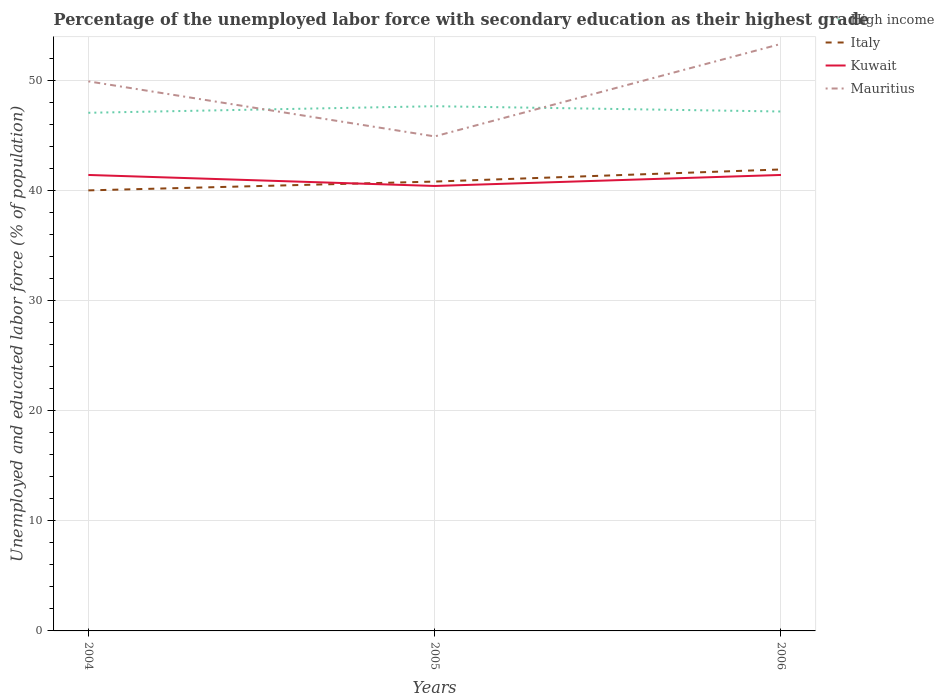How many different coloured lines are there?
Provide a short and direct response. 4. Is the number of lines equal to the number of legend labels?
Your answer should be very brief. Yes. What is the total percentage of the unemployed labor force with secondary education in Mauritius in the graph?
Provide a short and direct response. -3.4. What is the difference between the highest and the second highest percentage of the unemployed labor force with secondary education in Mauritius?
Offer a very short reply. 8.4. What is the difference between the highest and the lowest percentage of the unemployed labor force with secondary education in Italy?
Provide a succinct answer. 1. How many lines are there?
Ensure brevity in your answer.  4. What is the difference between two consecutive major ticks on the Y-axis?
Your answer should be compact. 10. Are the values on the major ticks of Y-axis written in scientific E-notation?
Your response must be concise. No. Does the graph contain any zero values?
Your answer should be very brief. No. How are the legend labels stacked?
Provide a short and direct response. Vertical. What is the title of the graph?
Your response must be concise. Percentage of the unemployed labor force with secondary education as their highest grade. What is the label or title of the X-axis?
Your answer should be compact. Years. What is the label or title of the Y-axis?
Make the answer very short. Unemployed and educated labor force (% of population). What is the Unemployed and educated labor force (% of population) of High income in 2004?
Keep it short and to the point. 47.05. What is the Unemployed and educated labor force (% of population) of Italy in 2004?
Your response must be concise. 40. What is the Unemployed and educated labor force (% of population) in Kuwait in 2004?
Ensure brevity in your answer.  41.4. What is the Unemployed and educated labor force (% of population) of Mauritius in 2004?
Make the answer very short. 49.9. What is the Unemployed and educated labor force (% of population) in High income in 2005?
Your answer should be very brief. 47.64. What is the Unemployed and educated labor force (% of population) in Italy in 2005?
Offer a terse response. 40.8. What is the Unemployed and educated labor force (% of population) of Kuwait in 2005?
Provide a short and direct response. 40.4. What is the Unemployed and educated labor force (% of population) of Mauritius in 2005?
Your response must be concise. 44.9. What is the Unemployed and educated labor force (% of population) of High income in 2006?
Offer a terse response. 47.16. What is the Unemployed and educated labor force (% of population) in Italy in 2006?
Provide a succinct answer. 41.9. What is the Unemployed and educated labor force (% of population) of Kuwait in 2006?
Keep it short and to the point. 41.4. What is the Unemployed and educated labor force (% of population) in Mauritius in 2006?
Provide a short and direct response. 53.3. Across all years, what is the maximum Unemployed and educated labor force (% of population) of High income?
Ensure brevity in your answer.  47.64. Across all years, what is the maximum Unemployed and educated labor force (% of population) in Italy?
Provide a short and direct response. 41.9. Across all years, what is the maximum Unemployed and educated labor force (% of population) of Kuwait?
Ensure brevity in your answer.  41.4. Across all years, what is the maximum Unemployed and educated labor force (% of population) in Mauritius?
Ensure brevity in your answer.  53.3. Across all years, what is the minimum Unemployed and educated labor force (% of population) in High income?
Provide a succinct answer. 47.05. Across all years, what is the minimum Unemployed and educated labor force (% of population) of Italy?
Ensure brevity in your answer.  40. Across all years, what is the minimum Unemployed and educated labor force (% of population) in Kuwait?
Provide a short and direct response. 40.4. Across all years, what is the minimum Unemployed and educated labor force (% of population) of Mauritius?
Your answer should be very brief. 44.9. What is the total Unemployed and educated labor force (% of population) in High income in the graph?
Keep it short and to the point. 141.85. What is the total Unemployed and educated labor force (% of population) in Italy in the graph?
Make the answer very short. 122.7. What is the total Unemployed and educated labor force (% of population) of Kuwait in the graph?
Provide a succinct answer. 123.2. What is the total Unemployed and educated labor force (% of population) in Mauritius in the graph?
Provide a succinct answer. 148.1. What is the difference between the Unemployed and educated labor force (% of population) in High income in 2004 and that in 2005?
Your answer should be compact. -0.6. What is the difference between the Unemployed and educated labor force (% of population) in Kuwait in 2004 and that in 2005?
Give a very brief answer. 1. What is the difference between the Unemployed and educated labor force (% of population) of High income in 2004 and that in 2006?
Your response must be concise. -0.12. What is the difference between the Unemployed and educated labor force (% of population) of Kuwait in 2004 and that in 2006?
Your answer should be very brief. 0. What is the difference between the Unemployed and educated labor force (% of population) in Mauritius in 2004 and that in 2006?
Your response must be concise. -3.4. What is the difference between the Unemployed and educated labor force (% of population) of High income in 2005 and that in 2006?
Offer a very short reply. 0.48. What is the difference between the Unemployed and educated labor force (% of population) of Italy in 2005 and that in 2006?
Provide a short and direct response. -1.1. What is the difference between the Unemployed and educated labor force (% of population) of Kuwait in 2005 and that in 2006?
Offer a very short reply. -1. What is the difference between the Unemployed and educated labor force (% of population) of High income in 2004 and the Unemployed and educated labor force (% of population) of Italy in 2005?
Make the answer very short. 6.25. What is the difference between the Unemployed and educated labor force (% of population) in High income in 2004 and the Unemployed and educated labor force (% of population) in Kuwait in 2005?
Ensure brevity in your answer.  6.65. What is the difference between the Unemployed and educated labor force (% of population) in High income in 2004 and the Unemployed and educated labor force (% of population) in Mauritius in 2005?
Provide a short and direct response. 2.15. What is the difference between the Unemployed and educated labor force (% of population) of Kuwait in 2004 and the Unemployed and educated labor force (% of population) of Mauritius in 2005?
Provide a succinct answer. -3.5. What is the difference between the Unemployed and educated labor force (% of population) in High income in 2004 and the Unemployed and educated labor force (% of population) in Italy in 2006?
Your answer should be very brief. 5.15. What is the difference between the Unemployed and educated labor force (% of population) of High income in 2004 and the Unemployed and educated labor force (% of population) of Kuwait in 2006?
Provide a short and direct response. 5.65. What is the difference between the Unemployed and educated labor force (% of population) of High income in 2004 and the Unemployed and educated labor force (% of population) of Mauritius in 2006?
Your answer should be compact. -6.25. What is the difference between the Unemployed and educated labor force (% of population) in Italy in 2004 and the Unemployed and educated labor force (% of population) in Kuwait in 2006?
Give a very brief answer. -1.4. What is the difference between the Unemployed and educated labor force (% of population) in Italy in 2004 and the Unemployed and educated labor force (% of population) in Mauritius in 2006?
Your answer should be compact. -13.3. What is the difference between the Unemployed and educated labor force (% of population) of High income in 2005 and the Unemployed and educated labor force (% of population) of Italy in 2006?
Offer a very short reply. 5.74. What is the difference between the Unemployed and educated labor force (% of population) in High income in 2005 and the Unemployed and educated labor force (% of population) in Kuwait in 2006?
Keep it short and to the point. 6.24. What is the difference between the Unemployed and educated labor force (% of population) of High income in 2005 and the Unemployed and educated labor force (% of population) of Mauritius in 2006?
Provide a short and direct response. -5.66. What is the difference between the Unemployed and educated labor force (% of population) of Italy in 2005 and the Unemployed and educated labor force (% of population) of Kuwait in 2006?
Your answer should be very brief. -0.6. What is the difference between the Unemployed and educated labor force (% of population) of Italy in 2005 and the Unemployed and educated labor force (% of population) of Mauritius in 2006?
Your answer should be very brief. -12.5. What is the difference between the Unemployed and educated labor force (% of population) of Kuwait in 2005 and the Unemployed and educated labor force (% of population) of Mauritius in 2006?
Your answer should be very brief. -12.9. What is the average Unemployed and educated labor force (% of population) in High income per year?
Keep it short and to the point. 47.28. What is the average Unemployed and educated labor force (% of population) in Italy per year?
Provide a succinct answer. 40.9. What is the average Unemployed and educated labor force (% of population) in Kuwait per year?
Keep it short and to the point. 41.07. What is the average Unemployed and educated labor force (% of population) in Mauritius per year?
Ensure brevity in your answer.  49.37. In the year 2004, what is the difference between the Unemployed and educated labor force (% of population) in High income and Unemployed and educated labor force (% of population) in Italy?
Give a very brief answer. 7.05. In the year 2004, what is the difference between the Unemployed and educated labor force (% of population) of High income and Unemployed and educated labor force (% of population) of Kuwait?
Ensure brevity in your answer.  5.65. In the year 2004, what is the difference between the Unemployed and educated labor force (% of population) in High income and Unemployed and educated labor force (% of population) in Mauritius?
Ensure brevity in your answer.  -2.85. In the year 2004, what is the difference between the Unemployed and educated labor force (% of population) in Italy and Unemployed and educated labor force (% of population) in Kuwait?
Your answer should be very brief. -1.4. In the year 2004, what is the difference between the Unemployed and educated labor force (% of population) of Kuwait and Unemployed and educated labor force (% of population) of Mauritius?
Ensure brevity in your answer.  -8.5. In the year 2005, what is the difference between the Unemployed and educated labor force (% of population) in High income and Unemployed and educated labor force (% of population) in Italy?
Provide a short and direct response. 6.84. In the year 2005, what is the difference between the Unemployed and educated labor force (% of population) in High income and Unemployed and educated labor force (% of population) in Kuwait?
Offer a terse response. 7.24. In the year 2005, what is the difference between the Unemployed and educated labor force (% of population) of High income and Unemployed and educated labor force (% of population) of Mauritius?
Offer a terse response. 2.74. In the year 2005, what is the difference between the Unemployed and educated labor force (% of population) in Italy and Unemployed and educated labor force (% of population) in Mauritius?
Provide a short and direct response. -4.1. In the year 2006, what is the difference between the Unemployed and educated labor force (% of population) in High income and Unemployed and educated labor force (% of population) in Italy?
Offer a terse response. 5.26. In the year 2006, what is the difference between the Unemployed and educated labor force (% of population) of High income and Unemployed and educated labor force (% of population) of Kuwait?
Offer a very short reply. 5.76. In the year 2006, what is the difference between the Unemployed and educated labor force (% of population) in High income and Unemployed and educated labor force (% of population) in Mauritius?
Provide a succinct answer. -6.14. In the year 2006, what is the difference between the Unemployed and educated labor force (% of population) in Italy and Unemployed and educated labor force (% of population) in Mauritius?
Ensure brevity in your answer.  -11.4. What is the ratio of the Unemployed and educated labor force (% of population) of High income in 2004 to that in 2005?
Your answer should be compact. 0.99. What is the ratio of the Unemployed and educated labor force (% of population) of Italy in 2004 to that in 2005?
Offer a terse response. 0.98. What is the ratio of the Unemployed and educated labor force (% of population) in Kuwait in 2004 to that in 2005?
Provide a short and direct response. 1.02. What is the ratio of the Unemployed and educated labor force (% of population) of Mauritius in 2004 to that in 2005?
Make the answer very short. 1.11. What is the ratio of the Unemployed and educated labor force (% of population) in Italy in 2004 to that in 2006?
Ensure brevity in your answer.  0.95. What is the ratio of the Unemployed and educated labor force (% of population) in Kuwait in 2004 to that in 2006?
Give a very brief answer. 1. What is the ratio of the Unemployed and educated labor force (% of population) in Mauritius in 2004 to that in 2006?
Your response must be concise. 0.94. What is the ratio of the Unemployed and educated labor force (% of population) in High income in 2005 to that in 2006?
Provide a succinct answer. 1.01. What is the ratio of the Unemployed and educated labor force (% of population) of Italy in 2005 to that in 2006?
Make the answer very short. 0.97. What is the ratio of the Unemployed and educated labor force (% of population) in Kuwait in 2005 to that in 2006?
Give a very brief answer. 0.98. What is the ratio of the Unemployed and educated labor force (% of population) of Mauritius in 2005 to that in 2006?
Provide a succinct answer. 0.84. What is the difference between the highest and the second highest Unemployed and educated labor force (% of population) in High income?
Your response must be concise. 0.48. What is the difference between the highest and the second highest Unemployed and educated labor force (% of population) in Italy?
Give a very brief answer. 1.1. What is the difference between the highest and the second highest Unemployed and educated labor force (% of population) of Kuwait?
Keep it short and to the point. 0. What is the difference between the highest and the lowest Unemployed and educated labor force (% of population) of High income?
Your response must be concise. 0.6. What is the difference between the highest and the lowest Unemployed and educated labor force (% of population) in Italy?
Ensure brevity in your answer.  1.9. What is the difference between the highest and the lowest Unemployed and educated labor force (% of population) of Kuwait?
Your answer should be compact. 1. 